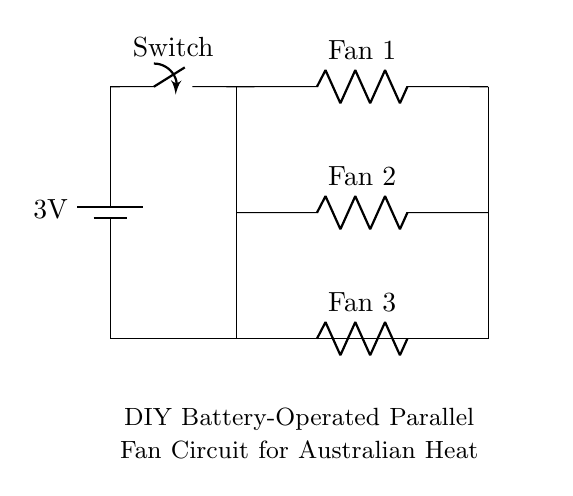What is the voltage of this circuit? The voltage is 3 volts, which is the value marked on the battery in the circuit diagram.
Answer: 3 volts What type of circuit is this? This is a parallel circuit as indicated by multiple branches that connect to the same two points (battery terminals).
Answer: Parallel How many fans are present in this circuit? There are three fans, as shown by the three resistors labeled Fan 1, Fan 2, and Fan 3 in the diagram.
Answer: Three What is the role of the switch in this circuit? The switch controls the flow of current by allowing or interrupting the connection between the battery and the fans.
Answer: Control current Which fan is connected to the highest point in the circuit? Fan 1 is connected to the highest point in the circuit, as it is the first branch after the switch.
Answer: Fan 1 If one fan fails, will the others still operate? Yes, in a parallel circuit, if one branch (fan) fails, the others remain functional because each branch connects directly to the voltage supply.
Answer: Yes What is the total voltage supplied to each fan? Each fan receives the same 3 volts from the battery because they are all connected in parallel to the same voltage source.
Answer: 3 volts 